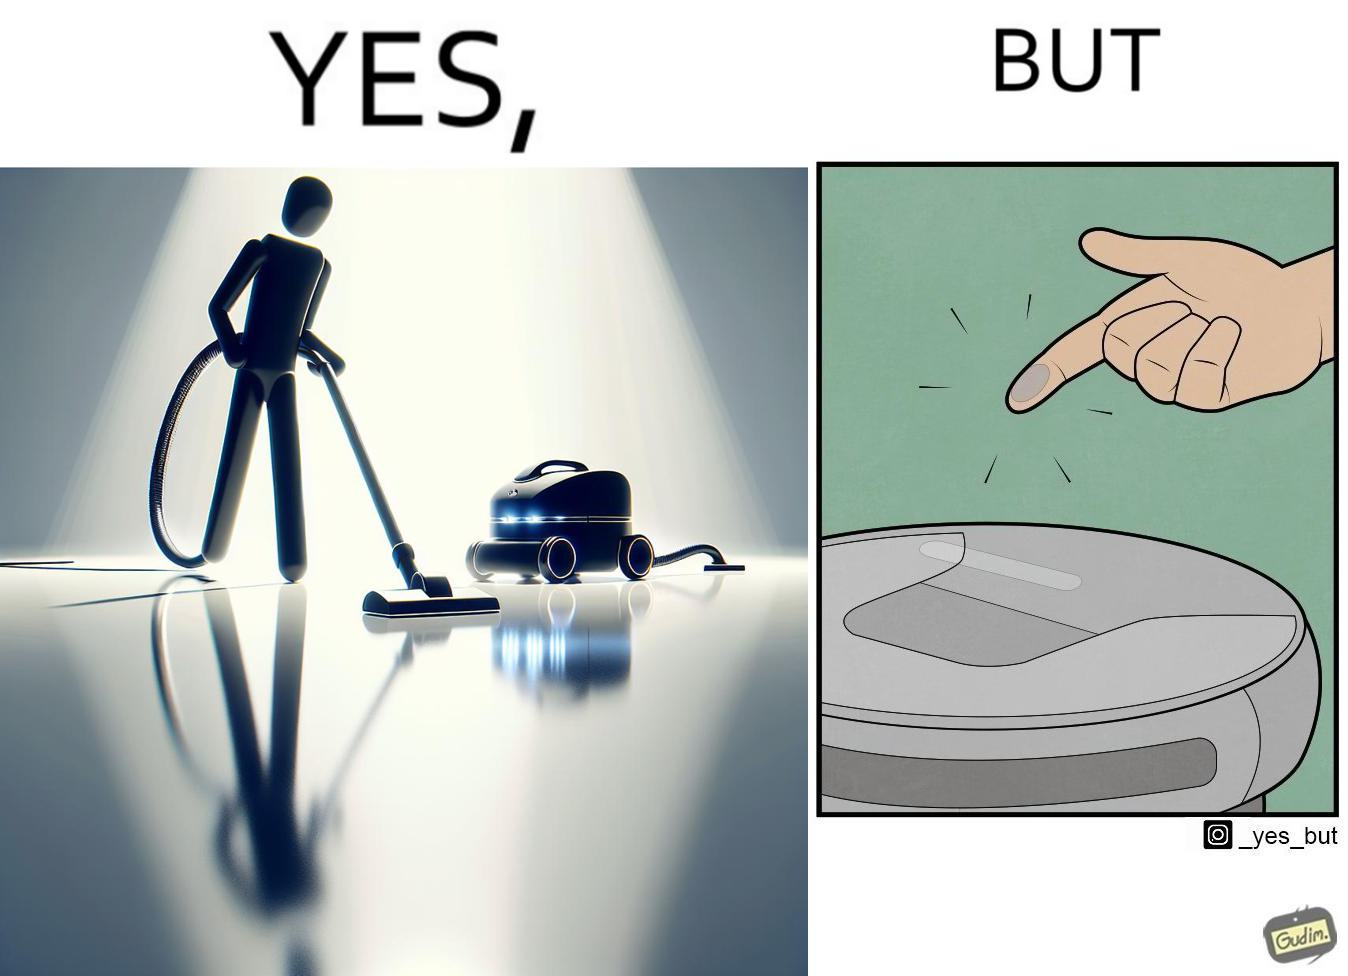Describe the content of this image. This is funny, because the machine while doing its job cleans everything but ends up being dirty itself. 